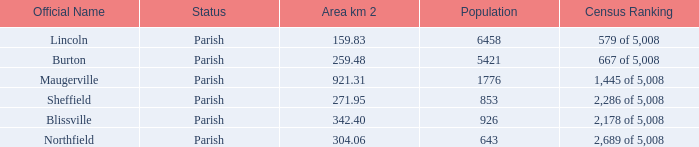06 km2? Northfield. 